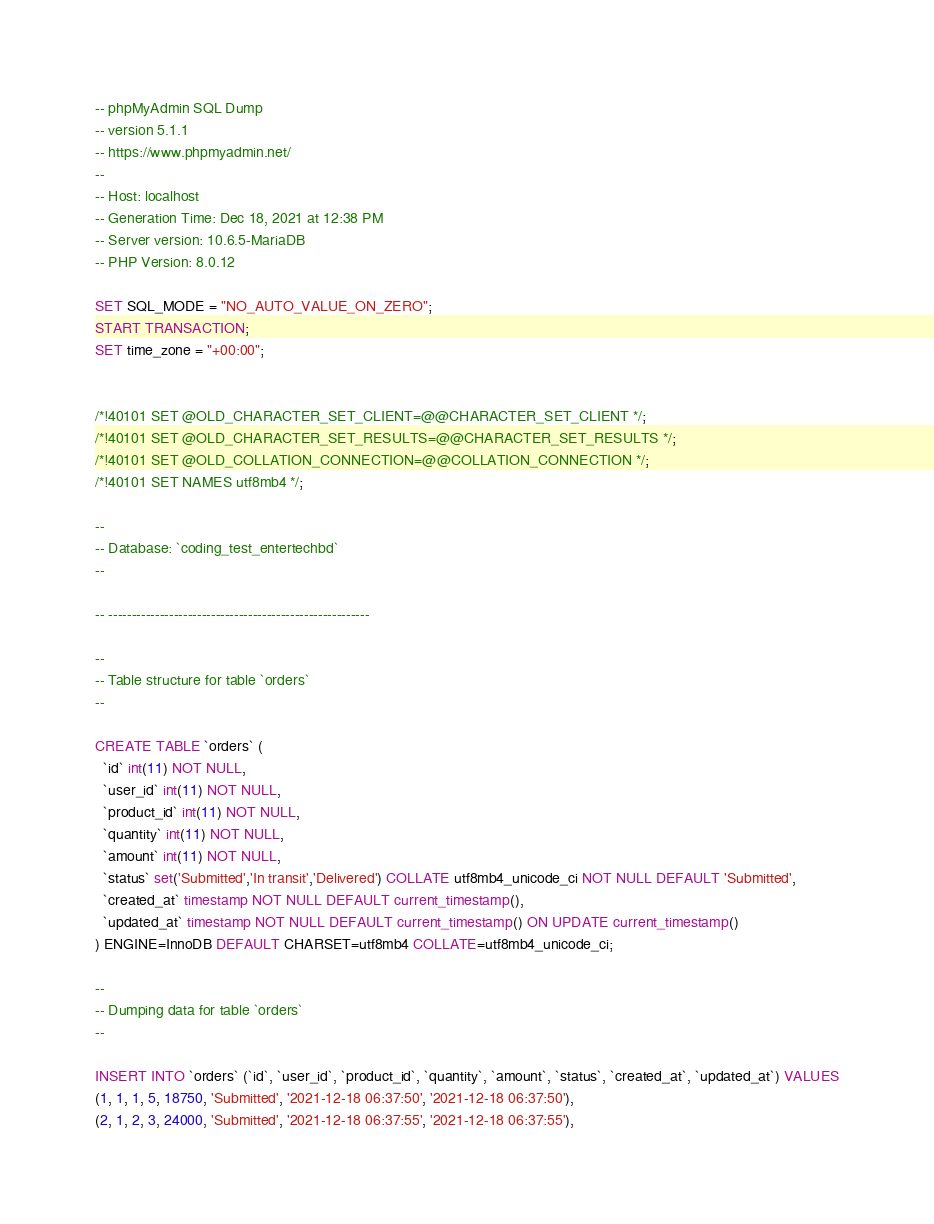Convert code to text. <code><loc_0><loc_0><loc_500><loc_500><_SQL_>-- phpMyAdmin SQL Dump
-- version 5.1.1
-- https://www.phpmyadmin.net/
--
-- Host: localhost
-- Generation Time: Dec 18, 2021 at 12:38 PM
-- Server version: 10.6.5-MariaDB
-- PHP Version: 8.0.12

SET SQL_MODE = "NO_AUTO_VALUE_ON_ZERO";
START TRANSACTION;
SET time_zone = "+00:00";


/*!40101 SET @OLD_CHARACTER_SET_CLIENT=@@CHARACTER_SET_CLIENT */;
/*!40101 SET @OLD_CHARACTER_SET_RESULTS=@@CHARACTER_SET_RESULTS */;
/*!40101 SET @OLD_COLLATION_CONNECTION=@@COLLATION_CONNECTION */;
/*!40101 SET NAMES utf8mb4 */;

--
-- Database: `coding_test_entertechbd`
--

-- --------------------------------------------------------

--
-- Table structure for table `orders`
--

CREATE TABLE `orders` (
  `id` int(11) NOT NULL,
  `user_id` int(11) NOT NULL,
  `product_id` int(11) NOT NULL,
  `quantity` int(11) NOT NULL,
  `amount` int(11) NOT NULL,
  `status` set('Submitted','In transit','Delivered') COLLATE utf8mb4_unicode_ci NOT NULL DEFAULT 'Submitted',
  `created_at` timestamp NOT NULL DEFAULT current_timestamp(),
  `updated_at` timestamp NOT NULL DEFAULT current_timestamp() ON UPDATE current_timestamp()
) ENGINE=InnoDB DEFAULT CHARSET=utf8mb4 COLLATE=utf8mb4_unicode_ci;

--
-- Dumping data for table `orders`
--

INSERT INTO `orders` (`id`, `user_id`, `product_id`, `quantity`, `amount`, `status`, `created_at`, `updated_at`) VALUES
(1, 1, 1, 5, 18750, 'Submitted', '2021-12-18 06:37:50', '2021-12-18 06:37:50'),
(2, 1, 2, 3, 24000, 'Submitted', '2021-12-18 06:37:55', '2021-12-18 06:37:55'),</code> 